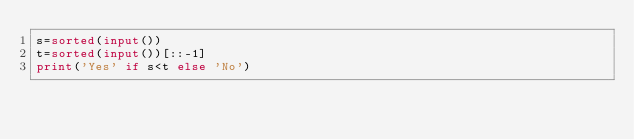Convert code to text. <code><loc_0><loc_0><loc_500><loc_500><_Python_>s=sorted(input())
t=sorted(input())[::-1]
print('Yes' if s<t else 'No')
</code> 